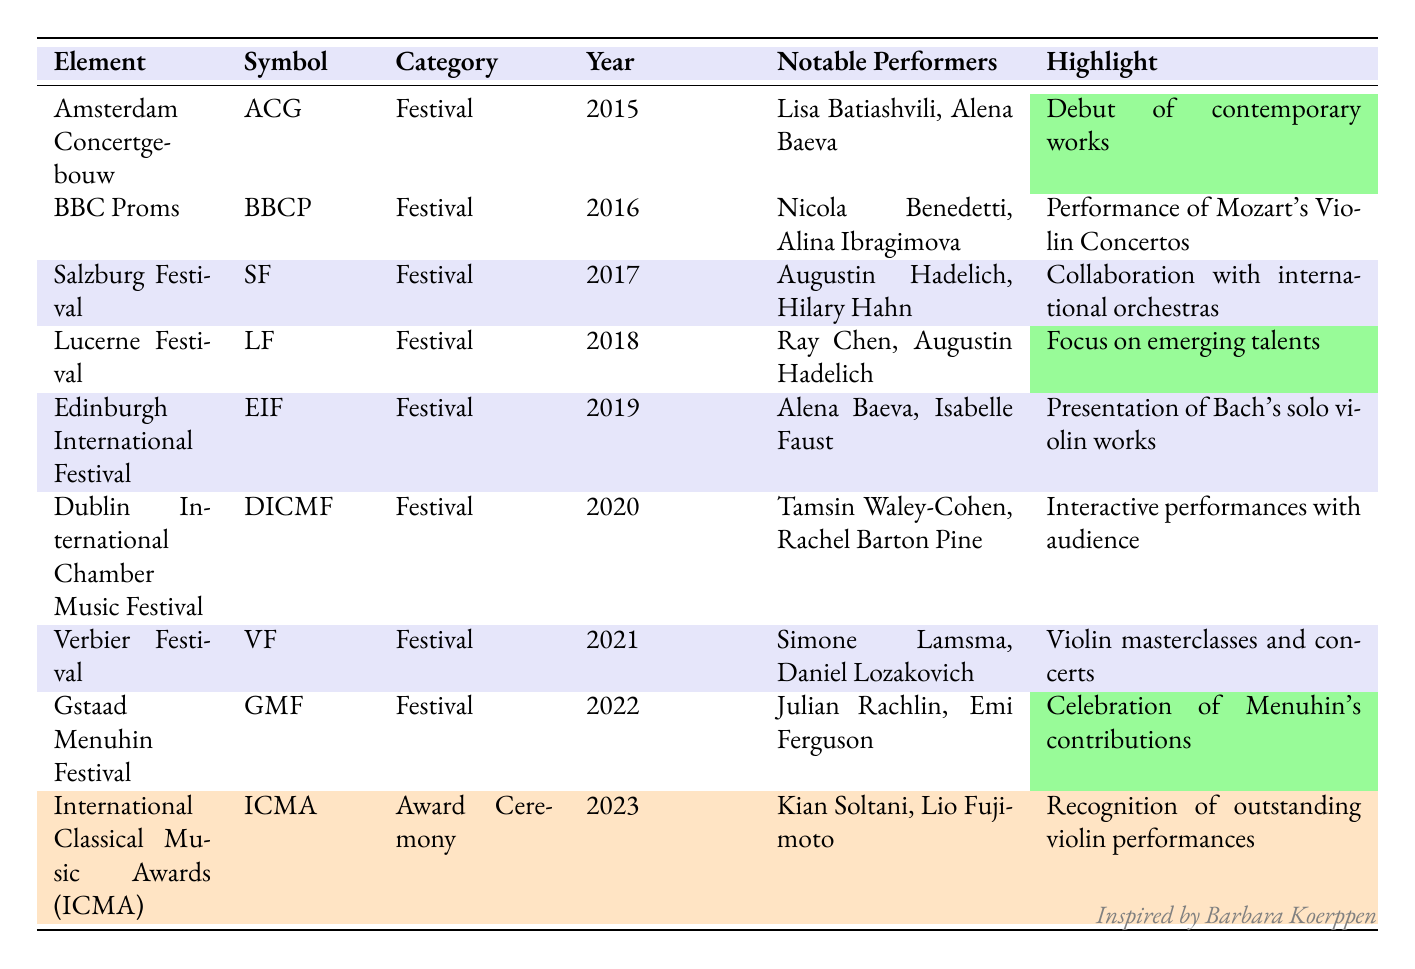What was the highlight of the BBC Proms in 2016? The highlight of the BBC Proms in 2016 was the performance of Mozart's Violin Concertos, as noted in the detail for that year in the table.
Answer: Performance of Mozart's Violin Concertos Which two violinists performed at the Amsterdam Concertgebouw in 2015? The table lists Lisa Batiashvili and Alena Baeva as the notable performers at the Amsterdam Concertgebouw in 2015.
Answer: Lisa Batiashvili, Alena Baeva Did the Gstaad Menuhin Festival take place in an odd year? The Gstaad Menuhin Festival took place in 2022, which is an even year; therefore, the statement is false.
Answer: No Which festival focused on presenting emerging talents? According to the table, the Lucerne Festival in 2018 focused on emerging talents as indicated in the highlight description.
Answer: Lucerne Festival What is the total number of festivals listed in the table? The table contains ten entries; nine festivals and one award ceremony. Since we are asked about festivals only, we count the nine festivals listed separately.
Answer: 9 Which violinist performed in both the Edinburgh International Festival and the Dublin International Chamber Music Festival? Reviewing the notable performers in the table, Alena Baeva is listed for the Edinburgh International Festival in 2019 and is also recognized for her performance at the same festival; she is not mentioned in the Dublin International Chamber Music Festival, so the answer is that there are no violinists who performed at both.
Answer: None Which festival had a highlight related to Bach's solo violin works? The highlight related to Bach's solo violin works is associated with the Edinburgh International Festival in 2019, as highlighted in the table.
Answer: Edinburgh International Festival Who were the notable performers at the International Classical Music Awards in 2023? The table states that Kian Soltani and Lio Fujimoto were the notable performers at the International Classical Music Awards in 2023.
Answer: Kian Soltani, Lio Fujimoto Was there a festival that specifically celebrated Menuhin's contributions? The table indicates that the Gstaad Menuhin Festival in 2022 celebrated Menuhin's contributions, thus confirming the statement as true.
Answer: Yes 